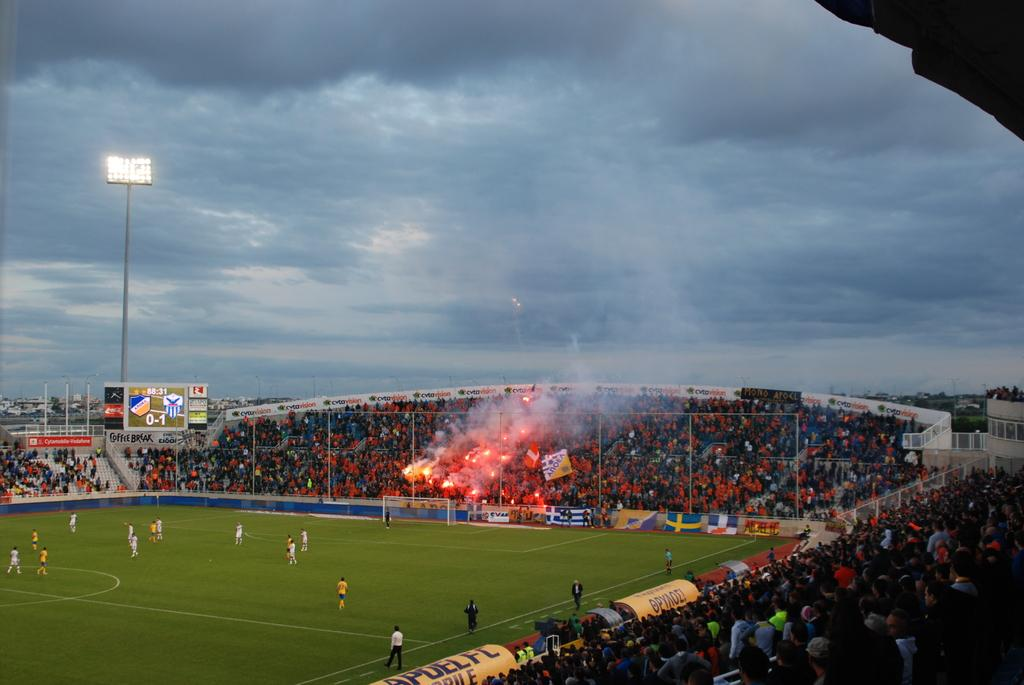Provide a one-sentence caption for the provided image. The scoreboard in the stadium shows that the score is currently 0-1. 